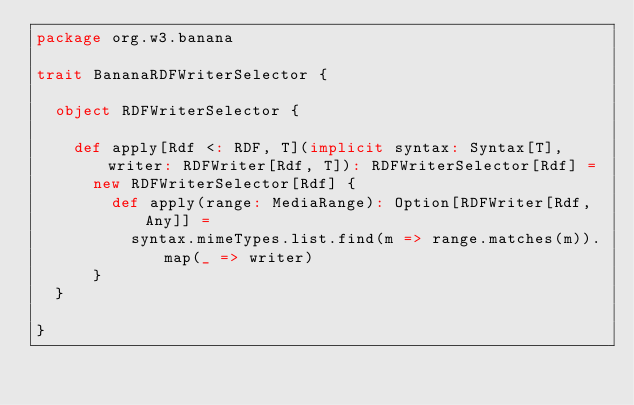<code> <loc_0><loc_0><loc_500><loc_500><_Scala_>package org.w3.banana

trait BananaRDFWriterSelector {

  object RDFWriterSelector {

    def apply[Rdf <: RDF, T](implicit syntax: Syntax[T], writer: RDFWriter[Rdf, T]): RDFWriterSelector[Rdf] =
      new RDFWriterSelector[Rdf] {
        def apply(range: MediaRange): Option[RDFWriter[Rdf, Any]] =
          syntax.mimeTypes.list.find(m => range.matches(m)).map(_ => writer)
      }
  }

}
</code> 